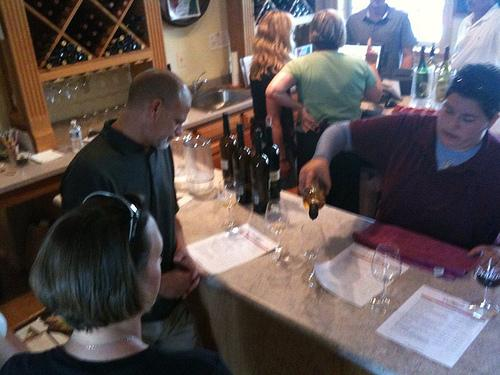What kind of wine is the man serving in the glasses? white 